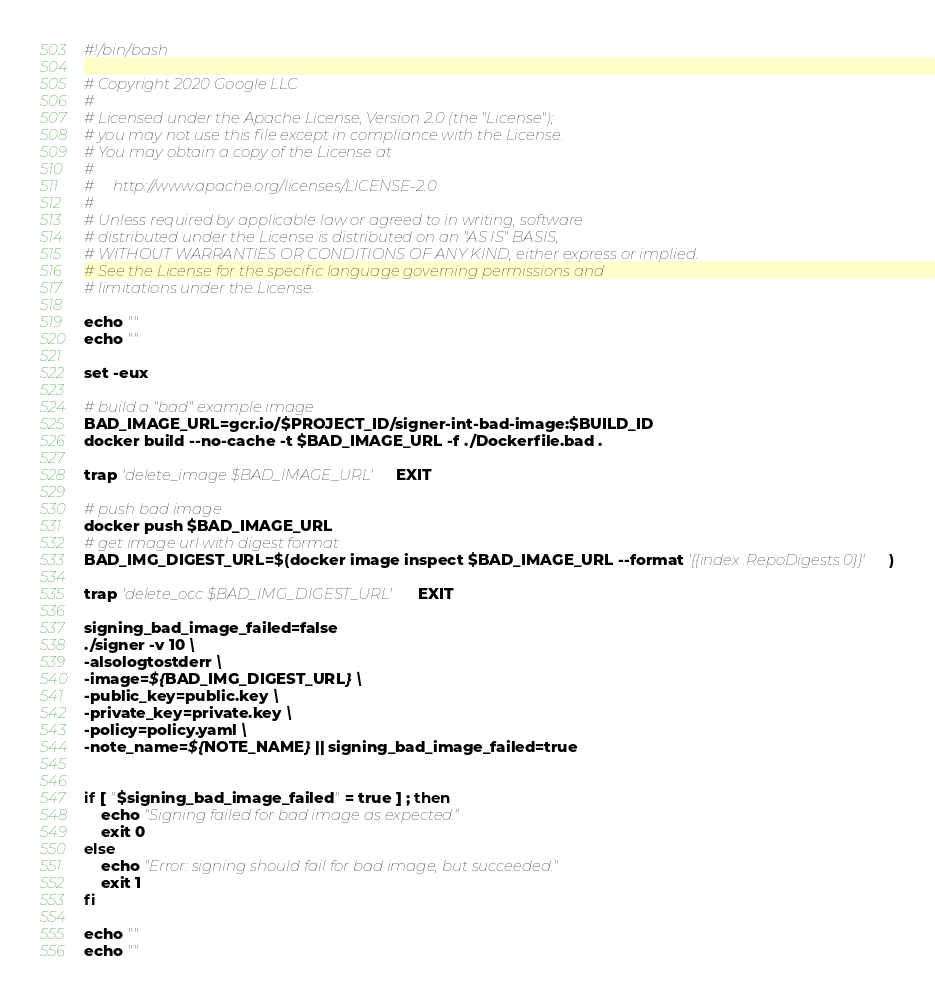Convert code to text. <code><loc_0><loc_0><loc_500><loc_500><_Bash_>#!/bin/bash

# Copyright 2020 Google LLC
#
# Licensed under the Apache License, Version 2.0 (the "License");
# you may not use this file except in compliance with the License.
# You may obtain a copy of the License at
#
#     http://www.apache.org/licenses/LICENSE-2.0
#
# Unless required by applicable law or agreed to in writing, software
# distributed under the License is distributed on an "AS IS" BASIS,
# WITHOUT WARRANTIES OR CONDITIONS OF ANY KIND, either express or implied.
# See the License for the specific language governing permissions and
# limitations under the License.

echo ""
echo ""

set -eux

# build a "bad" example image
BAD_IMAGE_URL=gcr.io/$PROJECT_ID/signer-int-bad-image:$BUILD_ID
docker build --no-cache -t $BAD_IMAGE_URL -f ./Dockerfile.bad .

trap 'delete_image $BAD_IMAGE_URL'  EXIT

# push bad image
docker push $BAD_IMAGE_URL
# get image url with digest format
BAD_IMG_DIGEST_URL=$(docker image inspect $BAD_IMAGE_URL --format '{{index .RepoDigests 0}}')

trap 'delete_occ $BAD_IMG_DIGEST_URL'  EXIT

signing_bad_image_failed=false
./signer -v 10 \
-alsologtostderr \
-image=${BAD_IMG_DIGEST_URL} \
-public_key=public.key \
-private_key=private.key \
-policy=policy.yaml \
-note_name=${NOTE_NAME} || signing_bad_image_failed=true


if [ "$signing_bad_image_failed" = true ] ; then
	echo "Signing failed for bad image as expected."
    exit 0
else
	echo "Error: signing should fail for bad image, but succeeded."
    exit 1
fi

echo ""
echo ""
</code> 